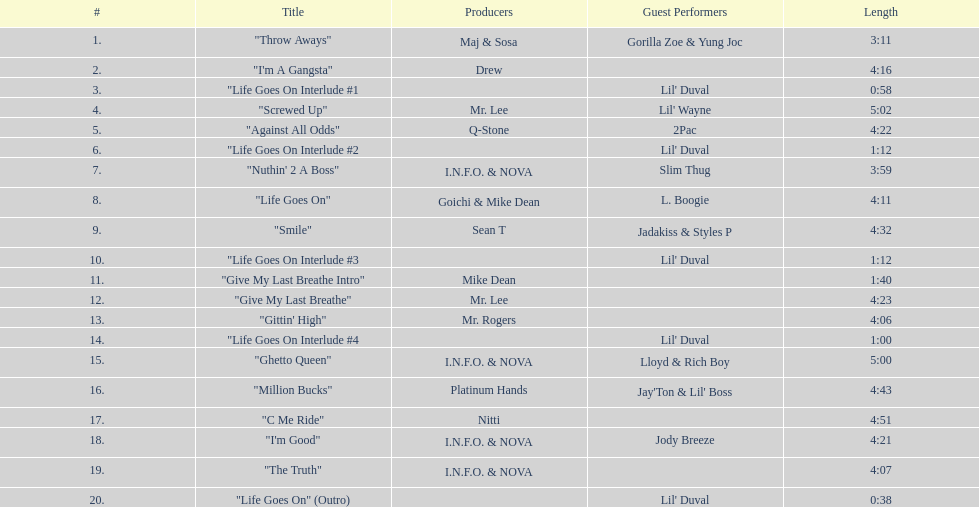What is the first track featuring lil' duval? "Life Goes On Interlude #1. 